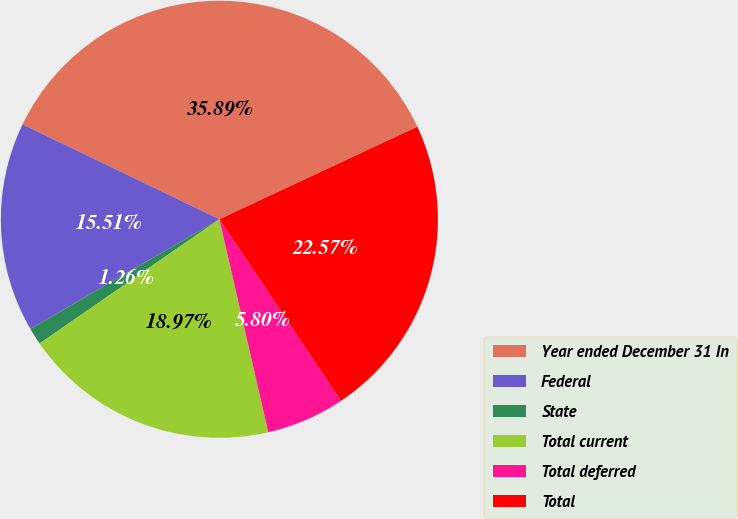Convert chart to OTSL. <chart><loc_0><loc_0><loc_500><loc_500><pie_chart><fcel>Year ended December 31 In<fcel>Federal<fcel>State<fcel>Total current<fcel>Total deferred<fcel>Total<nl><fcel>35.89%<fcel>15.51%<fcel>1.26%<fcel>18.97%<fcel>5.8%<fcel>22.57%<nl></chart> 